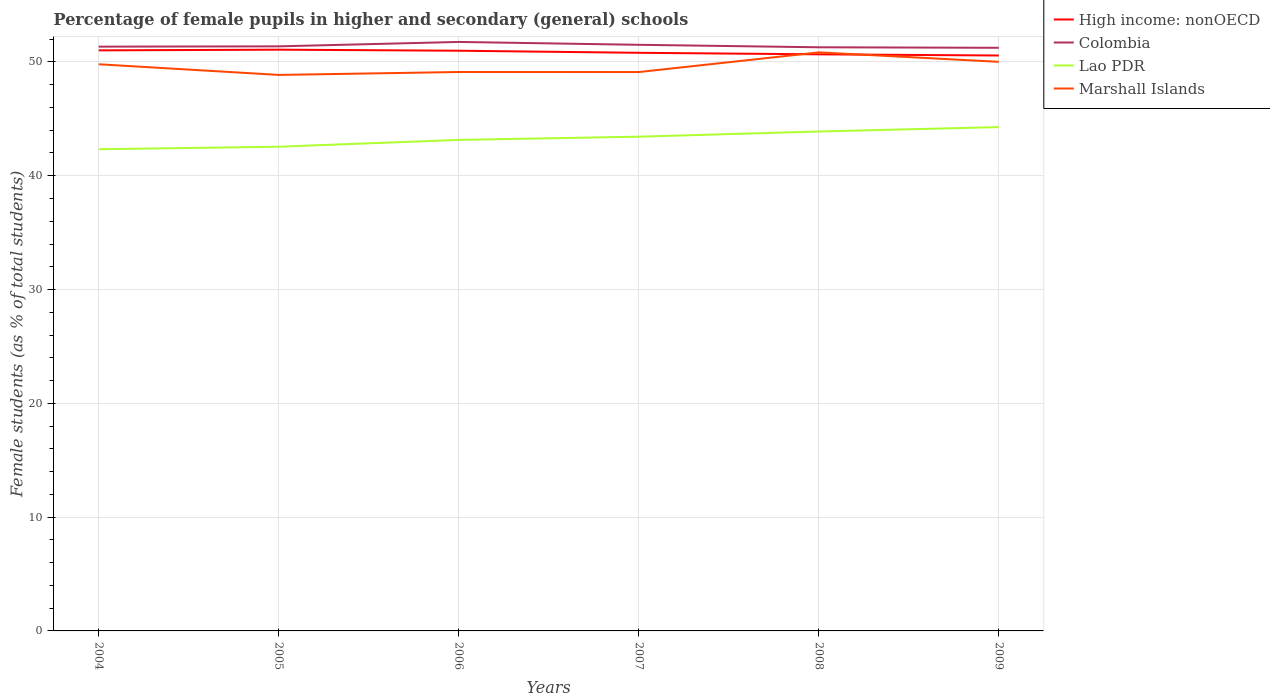Is the number of lines equal to the number of legend labels?
Provide a succinct answer. Yes. Across all years, what is the maximum percentage of female pupils in higher and secondary schools in High income: nonOECD?
Make the answer very short. 50.57. What is the total percentage of female pupils in higher and secondary schools in Colombia in the graph?
Provide a short and direct response. -0.03. What is the difference between the highest and the second highest percentage of female pupils in higher and secondary schools in Marshall Islands?
Your response must be concise. 1.98. Is the percentage of female pupils in higher and secondary schools in High income: nonOECD strictly greater than the percentage of female pupils in higher and secondary schools in Lao PDR over the years?
Your answer should be compact. No. How many lines are there?
Make the answer very short. 4. What is the difference between two consecutive major ticks on the Y-axis?
Your answer should be very brief. 10. Are the values on the major ticks of Y-axis written in scientific E-notation?
Your response must be concise. No. Does the graph contain any zero values?
Ensure brevity in your answer.  No. Does the graph contain grids?
Your answer should be very brief. Yes. How many legend labels are there?
Your answer should be very brief. 4. What is the title of the graph?
Provide a short and direct response. Percentage of female pupils in higher and secondary (general) schools. Does "Bhutan" appear as one of the legend labels in the graph?
Keep it short and to the point. No. What is the label or title of the Y-axis?
Give a very brief answer. Female students (as % of total students). What is the Female students (as % of total students) of High income: nonOECD in 2004?
Your answer should be compact. 51.02. What is the Female students (as % of total students) in Colombia in 2004?
Offer a terse response. 51.34. What is the Female students (as % of total students) in Lao PDR in 2004?
Make the answer very short. 42.33. What is the Female students (as % of total students) in Marshall Islands in 2004?
Offer a terse response. 49.79. What is the Female students (as % of total students) in High income: nonOECD in 2005?
Provide a succinct answer. 51.08. What is the Female students (as % of total students) in Colombia in 2005?
Ensure brevity in your answer.  51.37. What is the Female students (as % of total students) in Lao PDR in 2005?
Give a very brief answer. 42.55. What is the Female students (as % of total students) of Marshall Islands in 2005?
Your response must be concise. 48.86. What is the Female students (as % of total students) in High income: nonOECD in 2006?
Provide a succinct answer. 50.99. What is the Female students (as % of total students) of Colombia in 2006?
Provide a short and direct response. 51.76. What is the Female students (as % of total students) of Lao PDR in 2006?
Offer a terse response. 43.15. What is the Female students (as % of total students) in Marshall Islands in 2006?
Offer a terse response. 49.12. What is the Female students (as % of total students) in High income: nonOECD in 2007?
Provide a short and direct response. 50.8. What is the Female students (as % of total students) in Colombia in 2007?
Provide a short and direct response. 51.51. What is the Female students (as % of total students) in Lao PDR in 2007?
Your answer should be compact. 43.43. What is the Female students (as % of total students) in Marshall Islands in 2007?
Give a very brief answer. 49.11. What is the Female students (as % of total students) of High income: nonOECD in 2008?
Your response must be concise. 50.67. What is the Female students (as % of total students) of Colombia in 2008?
Ensure brevity in your answer.  51.29. What is the Female students (as % of total students) of Lao PDR in 2008?
Keep it short and to the point. 43.89. What is the Female students (as % of total students) in Marshall Islands in 2008?
Provide a succinct answer. 50.84. What is the Female students (as % of total students) in High income: nonOECD in 2009?
Offer a very short reply. 50.57. What is the Female students (as % of total students) of Colombia in 2009?
Make the answer very short. 51.24. What is the Female students (as % of total students) of Lao PDR in 2009?
Provide a succinct answer. 44.27. What is the Female students (as % of total students) in Marshall Islands in 2009?
Keep it short and to the point. 50.01. Across all years, what is the maximum Female students (as % of total students) in High income: nonOECD?
Provide a short and direct response. 51.08. Across all years, what is the maximum Female students (as % of total students) in Colombia?
Keep it short and to the point. 51.76. Across all years, what is the maximum Female students (as % of total students) of Lao PDR?
Offer a very short reply. 44.27. Across all years, what is the maximum Female students (as % of total students) in Marshall Islands?
Give a very brief answer. 50.84. Across all years, what is the minimum Female students (as % of total students) in High income: nonOECD?
Offer a terse response. 50.57. Across all years, what is the minimum Female students (as % of total students) of Colombia?
Your answer should be compact. 51.24. Across all years, what is the minimum Female students (as % of total students) of Lao PDR?
Your answer should be very brief. 42.33. Across all years, what is the minimum Female students (as % of total students) of Marshall Islands?
Your response must be concise. 48.86. What is the total Female students (as % of total students) of High income: nonOECD in the graph?
Offer a very short reply. 305.12. What is the total Female students (as % of total students) in Colombia in the graph?
Offer a very short reply. 308.51. What is the total Female students (as % of total students) in Lao PDR in the graph?
Offer a terse response. 259.62. What is the total Female students (as % of total students) in Marshall Islands in the graph?
Your answer should be very brief. 297.73. What is the difference between the Female students (as % of total students) of High income: nonOECD in 2004 and that in 2005?
Offer a terse response. -0.06. What is the difference between the Female students (as % of total students) in Colombia in 2004 and that in 2005?
Provide a succinct answer. -0.03. What is the difference between the Female students (as % of total students) in Lao PDR in 2004 and that in 2005?
Give a very brief answer. -0.22. What is the difference between the Female students (as % of total students) in Marshall Islands in 2004 and that in 2005?
Ensure brevity in your answer.  0.94. What is the difference between the Female students (as % of total students) in High income: nonOECD in 2004 and that in 2006?
Offer a very short reply. 0.03. What is the difference between the Female students (as % of total students) of Colombia in 2004 and that in 2006?
Your answer should be compact. -0.41. What is the difference between the Female students (as % of total students) of Lao PDR in 2004 and that in 2006?
Offer a very short reply. -0.82. What is the difference between the Female students (as % of total students) of Marshall Islands in 2004 and that in 2006?
Ensure brevity in your answer.  0.68. What is the difference between the Female students (as % of total students) in High income: nonOECD in 2004 and that in 2007?
Your answer should be compact. 0.21. What is the difference between the Female students (as % of total students) of Colombia in 2004 and that in 2007?
Offer a terse response. -0.16. What is the difference between the Female students (as % of total students) in Lao PDR in 2004 and that in 2007?
Your answer should be very brief. -1.1. What is the difference between the Female students (as % of total students) in Marshall Islands in 2004 and that in 2007?
Provide a short and direct response. 0.68. What is the difference between the Female students (as % of total students) in High income: nonOECD in 2004 and that in 2008?
Your answer should be very brief. 0.35. What is the difference between the Female students (as % of total students) in Colombia in 2004 and that in 2008?
Your answer should be very brief. 0.06. What is the difference between the Female students (as % of total students) of Lao PDR in 2004 and that in 2008?
Offer a very short reply. -1.56. What is the difference between the Female students (as % of total students) in Marshall Islands in 2004 and that in 2008?
Provide a succinct answer. -1.05. What is the difference between the Female students (as % of total students) in High income: nonOECD in 2004 and that in 2009?
Your answer should be very brief. 0.45. What is the difference between the Female students (as % of total students) in Colombia in 2004 and that in 2009?
Offer a terse response. 0.1. What is the difference between the Female students (as % of total students) of Lao PDR in 2004 and that in 2009?
Provide a succinct answer. -1.95. What is the difference between the Female students (as % of total students) in Marshall Islands in 2004 and that in 2009?
Ensure brevity in your answer.  -0.21. What is the difference between the Female students (as % of total students) in High income: nonOECD in 2005 and that in 2006?
Offer a terse response. 0.09. What is the difference between the Female students (as % of total students) of Colombia in 2005 and that in 2006?
Your answer should be compact. -0.39. What is the difference between the Female students (as % of total students) of Lao PDR in 2005 and that in 2006?
Offer a very short reply. -0.6. What is the difference between the Female students (as % of total students) in Marshall Islands in 2005 and that in 2006?
Keep it short and to the point. -0.26. What is the difference between the Female students (as % of total students) of High income: nonOECD in 2005 and that in 2007?
Your answer should be very brief. 0.28. What is the difference between the Female students (as % of total students) of Colombia in 2005 and that in 2007?
Provide a short and direct response. -0.14. What is the difference between the Female students (as % of total students) of Lao PDR in 2005 and that in 2007?
Provide a succinct answer. -0.88. What is the difference between the Female students (as % of total students) of Marshall Islands in 2005 and that in 2007?
Offer a very short reply. -0.25. What is the difference between the Female students (as % of total students) in High income: nonOECD in 2005 and that in 2008?
Provide a short and direct response. 0.41. What is the difference between the Female students (as % of total students) in Colombia in 2005 and that in 2008?
Your answer should be very brief. 0.08. What is the difference between the Female students (as % of total students) in Lao PDR in 2005 and that in 2008?
Give a very brief answer. -1.34. What is the difference between the Female students (as % of total students) in Marshall Islands in 2005 and that in 2008?
Offer a very short reply. -1.98. What is the difference between the Female students (as % of total students) in High income: nonOECD in 2005 and that in 2009?
Your answer should be very brief. 0.51. What is the difference between the Female students (as % of total students) of Colombia in 2005 and that in 2009?
Your answer should be compact. 0.13. What is the difference between the Female students (as % of total students) in Lao PDR in 2005 and that in 2009?
Give a very brief answer. -1.72. What is the difference between the Female students (as % of total students) of Marshall Islands in 2005 and that in 2009?
Provide a succinct answer. -1.15. What is the difference between the Female students (as % of total students) in High income: nonOECD in 2006 and that in 2007?
Offer a very short reply. 0.18. What is the difference between the Female students (as % of total students) of Colombia in 2006 and that in 2007?
Your answer should be very brief. 0.25. What is the difference between the Female students (as % of total students) in Lao PDR in 2006 and that in 2007?
Offer a very short reply. -0.28. What is the difference between the Female students (as % of total students) of Marshall Islands in 2006 and that in 2007?
Offer a terse response. 0. What is the difference between the Female students (as % of total students) of High income: nonOECD in 2006 and that in 2008?
Keep it short and to the point. 0.32. What is the difference between the Female students (as % of total students) in Colombia in 2006 and that in 2008?
Provide a short and direct response. 0.47. What is the difference between the Female students (as % of total students) of Lao PDR in 2006 and that in 2008?
Provide a succinct answer. -0.74. What is the difference between the Female students (as % of total students) in Marshall Islands in 2006 and that in 2008?
Your answer should be compact. -1.72. What is the difference between the Female students (as % of total students) of High income: nonOECD in 2006 and that in 2009?
Ensure brevity in your answer.  0.42. What is the difference between the Female students (as % of total students) of Colombia in 2006 and that in 2009?
Your answer should be very brief. 0.51. What is the difference between the Female students (as % of total students) of Lao PDR in 2006 and that in 2009?
Offer a terse response. -1.12. What is the difference between the Female students (as % of total students) of Marshall Islands in 2006 and that in 2009?
Offer a terse response. -0.89. What is the difference between the Female students (as % of total students) in High income: nonOECD in 2007 and that in 2008?
Keep it short and to the point. 0.13. What is the difference between the Female students (as % of total students) in Colombia in 2007 and that in 2008?
Your answer should be compact. 0.22. What is the difference between the Female students (as % of total students) in Lao PDR in 2007 and that in 2008?
Offer a very short reply. -0.46. What is the difference between the Female students (as % of total students) of Marshall Islands in 2007 and that in 2008?
Keep it short and to the point. -1.73. What is the difference between the Female students (as % of total students) of High income: nonOECD in 2007 and that in 2009?
Keep it short and to the point. 0.24. What is the difference between the Female students (as % of total students) of Colombia in 2007 and that in 2009?
Keep it short and to the point. 0.26. What is the difference between the Female students (as % of total students) of Lao PDR in 2007 and that in 2009?
Ensure brevity in your answer.  -0.84. What is the difference between the Female students (as % of total students) of Marshall Islands in 2007 and that in 2009?
Offer a terse response. -0.9. What is the difference between the Female students (as % of total students) in High income: nonOECD in 2008 and that in 2009?
Provide a succinct answer. 0.1. What is the difference between the Female students (as % of total students) of Colombia in 2008 and that in 2009?
Offer a very short reply. 0.04. What is the difference between the Female students (as % of total students) of Lao PDR in 2008 and that in 2009?
Make the answer very short. -0.38. What is the difference between the Female students (as % of total students) in Marshall Islands in 2008 and that in 2009?
Ensure brevity in your answer.  0.83. What is the difference between the Female students (as % of total students) in High income: nonOECD in 2004 and the Female students (as % of total students) in Colombia in 2005?
Give a very brief answer. -0.35. What is the difference between the Female students (as % of total students) of High income: nonOECD in 2004 and the Female students (as % of total students) of Lao PDR in 2005?
Ensure brevity in your answer.  8.47. What is the difference between the Female students (as % of total students) of High income: nonOECD in 2004 and the Female students (as % of total students) of Marshall Islands in 2005?
Make the answer very short. 2.16. What is the difference between the Female students (as % of total students) in Colombia in 2004 and the Female students (as % of total students) in Lao PDR in 2005?
Your answer should be compact. 8.79. What is the difference between the Female students (as % of total students) in Colombia in 2004 and the Female students (as % of total students) in Marshall Islands in 2005?
Give a very brief answer. 2.48. What is the difference between the Female students (as % of total students) in Lao PDR in 2004 and the Female students (as % of total students) in Marshall Islands in 2005?
Offer a very short reply. -6.53. What is the difference between the Female students (as % of total students) of High income: nonOECD in 2004 and the Female students (as % of total students) of Colombia in 2006?
Offer a terse response. -0.74. What is the difference between the Female students (as % of total students) of High income: nonOECD in 2004 and the Female students (as % of total students) of Lao PDR in 2006?
Keep it short and to the point. 7.87. What is the difference between the Female students (as % of total students) of High income: nonOECD in 2004 and the Female students (as % of total students) of Marshall Islands in 2006?
Ensure brevity in your answer.  1.9. What is the difference between the Female students (as % of total students) in Colombia in 2004 and the Female students (as % of total students) in Lao PDR in 2006?
Give a very brief answer. 8.19. What is the difference between the Female students (as % of total students) in Colombia in 2004 and the Female students (as % of total students) in Marshall Islands in 2006?
Your answer should be very brief. 2.23. What is the difference between the Female students (as % of total students) in Lao PDR in 2004 and the Female students (as % of total students) in Marshall Islands in 2006?
Ensure brevity in your answer.  -6.79. What is the difference between the Female students (as % of total students) in High income: nonOECD in 2004 and the Female students (as % of total students) in Colombia in 2007?
Your answer should be compact. -0.49. What is the difference between the Female students (as % of total students) of High income: nonOECD in 2004 and the Female students (as % of total students) of Lao PDR in 2007?
Provide a succinct answer. 7.59. What is the difference between the Female students (as % of total students) in High income: nonOECD in 2004 and the Female students (as % of total students) in Marshall Islands in 2007?
Offer a very short reply. 1.91. What is the difference between the Female students (as % of total students) in Colombia in 2004 and the Female students (as % of total students) in Lao PDR in 2007?
Offer a very short reply. 7.91. What is the difference between the Female students (as % of total students) of Colombia in 2004 and the Female students (as % of total students) of Marshall Islands in 2007?
Your answer should be compact. 2.23. What is the difference between the Female students (as % of total students) of Lao PDR in 2004 and the Female students (as % of total students) of Marshall Islands in 2007?
Offer a very short reply. -6.78. What is the difference between the Female students (as % of total students) of High income: nonOECD in 2004 and the Female students (as % of total students) of Colombia in 2008?
Ensure brevity in your answer.  -0.27. What is the difference between the Female students (as % of total students) in High income: nonOECD in 2004 and the Female students (as % of total students) in Lao PDR in 2008?
Offer a terse response. 7.13. What is the difference between the Female students (as % of total students) in High income: nonOECD in 2004 and the Female students (as % of total students) in Marshall Islands in 2008?
Ensure brevity in your answer.  0.18. What is the difference between the Female students (as % of total students) of Colombia in 2004 and the Female students (as % of total students) of Lao PDR in 2008?
Provide a short and direct response. 7.45. What is the difference between the Female students (as % of total students) in Colombia in 2004 and the Female students (as % of total students) in Marshall Islands in 2008?
Give a very brief answer. 0.5. What is the difference between the Female students (as % of total students) in Lao PDR in 2004 and the Female students (as % of total students) in Marshall Islands in 2008?
Provide a short and direct response. -8.51. What is the difference between the Female students (as % of total students) of High income: nonOECD in 2004 and the Female students (as % of total students) of Colombia in 2009?
Keep it short and to the point. -0.23. What is the difference between the Female students (as % of total students) of High income: nonOECD in 2004 and the Female students (as % of total students) of Lao PDR in 2009?
Your response must be concise. 6.74. What is the difference between the Female students (as % of total students) of High income: nonOECD in 2004 and the Female students (as % of total students) of Marshall Islands in 2009?
Provide a short and direct response. 1.01. What is the difference between the Female students (as % of total students) in Colombia in 2004 and the Female students (as % of total students) in Lao PDR in 2009?
Offer a terse response. 7.07. What is the difference between the Female students (as % of total students) in Colombia in 2004 and the Female students (as % of total students) in Marshall Islands in 2009?
Give a very brief answer. 1.33. What is the difference between the Female students (as % of total students) in Lao PDR in 2004 and the Female students (as % of total students) in Marshall Islands in 2009?
Provide a succinct answer. -7.68. What is the difference between the Female students (as % of total students) of High income: nonOECD in 2005 and the Female students (as % of total students) of Colombia in 2006?
Give a very brief answer. -0.68. What is the difference between the Female students (as % of total students) in High income: nonOECD in 2005 and the Female students (as % of total students) in Lao PDR in 2006?
Your response must be concise. 7.93. What is the difference between the Female students (as % of total students) in High income: nonOECD in 2005 and the Female students (as % of total students) in Marshall Islands in 2006?
Give a very brief answer. 1.96. What is the difference between the Female students (as % of total students) in Colombia in 2005 and the Female students (as % of total students) in Lao PDR in 2006?
Provide a succinct answer. 8.22. What is the difference between the Female students (as % of total students) of Colombia in 2005 and the Female students (as % of total students) of Marshall Islands in 2006?
Your response must be concise. 2.25. What is the difference between the Female students (as % of total students) of Lao PDR in 2005 and the Female students (as % of total students) of Marshall Islands in 2006?
Your answer should be compact. -6.57. What is the difference between the Female students (as % of total students) in High income: nonOECD in 2005 and the Female students (as % of total students) in Colombia in 2007?
Your answer should be compact. -0.43. What is the difference between the Female students (as % of total students) of High income: nonOECD in 2005 and the Female students (as % of total students) of Lao PDR in 2007?
Your answer should be compact. 7.65. What is the difference between the Female students (as % of total students) of High income: nonOECD in 2005 and the Female students (as % of total students) of Marshall Islands in 2007?
Ensure brevity in your answer.  1.97. What is the difference between the Female students (as % of total students) in Colombia in 2005 and the Female students (as % of total students) in Lao PDR in 2007?
Offer a terse response. 7.94. What is the difference between the Female students (as % of total students) of Colombia in 2005 and the Female students (as % of total students) of Marshall Islands in 2007?
Your answer should be very brief. 2.26. What is the difference between the Female students (as % of total students) of Lao PDR in 2005 and the Female students (as % of total students) of Marshall Islands in 2007?
Keep it short and to the point. -6.56. What is the difference between the Female students (as % of total students) of High income: nonOECD in 2005 and the Female students (as % of total students) of Colombia in 2008?
Offer a terse response. -0.21. What is the difference between the Female students (as % of total students) in High income: nonOECD in 2005 and the Female students (as % of total students) in Lao PDR in 2008?
Ensure brevity in your answer.  7.19. What is the difference between the Female students (as % of total students) in High income: nonOECD in 2005 and the Female students (as % of total students) in Marshall Islands in 2008?
Offer a terse response. 0.24. What is the difference between the Female students (as % of total students) of Colombia in 2005 and the Female students (as % of total students) of Lao PDR in 2008?
Provide a succinct answer. 7.48. What is the difference between the Female students (as % of total students) in Colombia in 2005 and the Female students (as % of total students) in Marshall Islands in 2008?
Give a very brief answer. 0.53. What is the difference between the Female students (as % of total students) of Lao PDR in 2005 and the Female students (as % of total students) of Marshall Islands in 2008?
Provide a short and direct response. -8.29. What is the difference between the Female students (as % of total students) in High income: nonOECD in 2005 and the Female students (as % of total students) in Colombia in 2009?
Make the answer very short. -0.16. What is the difference between the Female students (as % of total students) of High income: nonOECD in 2005 and the Female students (as % of total students) of Lao PDR in 2009?
Keep it short and to the point. 6.8. What is the difference between the Female students (as % of total students) of High income: nonOECD in 2005 and the Female students (as % of total students) of Marshall Islands in 2009?
Your answer should be compact. 1.07. What is the difference between the Female students (as % of total students) of Colombia in 2005 and the Female students (as % of total students) of Lao PDR in 2009?
Give a very brief answer. 7.1. What is the difference between the Female students (as % of total students) in Colombia in 2005 and the Female students (as % of total students) in Marshall Islands in 2009?
Your response must be concise. 1.36. What is the difference between the Female students (as % of total students) in Lao PDR in 2005 and the Female students (as % of total students) in Marshall Islands in 2009?
Keep it short and to the point. -7.46. What is the difference between the Female students (as % of total students) of High income: nonOECD in 2006 and the Female students (as % of total students) of Colombia in 2007?
Provide a succinct answer. -0.52. What is the difference between the Female students (as % of total students) of High income: nonOECD in 2006 and the Female students (as % of total students) of Lao PDR in 2007?
Your answer should be very brief. 7.55. What is the difference between the Female students (as % of total students) of High income: nonOECD in 2006 and the Female students (as % of total students) of Marshall Islands in 2007?
Give a very brief answer. 1.88. What is the difference between the Female students (as % of total students) in Colombia in 2006 and the Female students (as % of total students) in Lao PDR in 2007?
Offer a very short reply. 8.33. What is the difference between the Female students (as % of total students) in Colombia in 2006 and the Female students (as % of total students) in Marshall Islands in 2007?
Your answer should be very brief. 2.65. What is the difference between the Female students (as % of total students) of Lao PDR in 2006 and the Female students (as % of total students) of Marshall Islands in 2007?
Keep it short and to the point. -5.96. What is the difference between the Female students (as % of total students) of High income: nonOECD in 2006 and the Female students (as % of total students) of Colombia in 2008?
Offer a terse response. -0.3. What is the difference between the Female students (as % of total students) in High income: nonOECD in 2006 and the Female students (as % of total students) in Lao PDR in 2008?
Make the answer very short. 7.1. What is the difference between the Female students (as % of total students) of High income: nonOECD in 2006 and the Female students (as % of total students) of Marshall Islands in 2008?
Provide a short and direct response. 0.15. What is the difference between the Female students (as % of total students) in Colombia in 2006 and the Female students (as % of total students) in Lao PDR in 2008?
Provide a short and direct response. 7.87. What is the difference between the Female students (as % of total students) in Colombia in 2006 and the Female students (as % of total students) in Marshall Islands in 2008?
Provide a succinct answer. 0.92. What is the difference between the Female students (as % of total students) in Lao PDR in 2006 and the Female students (as % of total students) in Marshall Islands in 2008?
Your answer should be compact. -7.69. What is the difference between the Female students (as % of total students) in High income: nonOECD in 2006 and the Female students (as % of total students) in Colombia in 2009?
Offer a very short reply. -0.26. What is the difference between the Female students (as % of total students) in High income: nonOECD in 2006 and the Female students (as % of total students) in Lao PDR in 2009?
Offer a very short reply. 6.71. What is the difference between the Female students (as % of total students) of High income: nonOECD in 2006 and the Female students (as % of total students) of Marshall Islands in 2009?
Make the answer very short. 0.98. What is the difference between the Female students (as % of total students) of Colombia in 2006 and the Female students (as % of total students) of Lao PDR in 2009?
Offer a very short reply. 7.48. What is the difference between the Female students (as % of total students) in Colombia in 2006 and the Female students (as % of total students) in Marshall Islands in 2009?
Your answer should be very brief. 1.75. What is the difference between the Female students (as % of total students) of Lao PDR in 2006 and the Female students (as % of total students) of Marshall Islands in 2009?
Offer a very short reply. -6.86. What is the difference between the Female students (as % of total students) of High income: nonOECD in 2007 and the Female students (as % of total students) of Colombia in 2008?
Keep it short and to the point. -0.48. What is the difference between the Female students (as % of total students) of High income: nonOECD in 2007 and the Female students (as % of total students) of Lao PDR in 2008?
Make the answer very short. 6.91. What is the difference between the Female students (as % of total students) in High income: nonOECD in 2007 and the Female students (as % of total students) in Marshall Islands in 2008?
Your response must be concise. -0.04. What is the difference between the Female students (as % of total students) in Colombia in 2007 and the Female students (as % of total students) in Lao PDR in 2008?
Make the answer very short. 7.62. What is the difference between the Female students (as % of total students) in Colombia in 2007 and the Female students (as % of total students) in Marshall Islands in 2008?
Provide a succinct answer. 0.67. What is the difference between the Female students (as % of total students) in Lao PDR in 2007 and the Female students (as % of total students) in Marshall Islands in 2008?
Your answer should be very brief. -7.41. What is the difference between the Female students (as % of total students) of High income: nonOECD in 2007 and the Female students (as % of total students) of Colombia in 2009?
Keep it short and to the point. -0.44. What is the difference between the Female students (as % of total students) of High income: nonOECD in 2007 and the Female students (as % of total students) of Lao PDR in 2009?
Offer a terse response. 6.53. What is the difference between the Female students (as % of total students) in High income: nonOECD in 2007 and the Female students (as % of total students) in Marshall Islands in 2009?
Offer a very short reply. 0.79. What is the difference between the Female students (as % of total students) of Colombia in 2007 and the Female students (as % of total students) of Lao PDR in 2009?
Give a very brief answer. 7.23. What is the difference between the Female students (as % of total students) in Colombia in 2007 and the Female students (as % of total students) in Marshall Islands in 2009?
Ensure brevity in your answer.  1.5. What is the difference between the Female students (as % of total students) in Lao PDR in 2007 and the Female students (as % of total students) in Marshall Islands in 2009?
Offer a terse response. -6.58. What is the difference between the Female students (as % of total students) in High income: nonOECD in 2008 and the Female students (as % of total students) in Colombia in 2009?
Provide a short and direct response. -0.57. What is the difference between the Female students (as % of total students) in High income: nonOECD in 2008 and the Female students (as % of total students) in Lao PDR in 2009?
Ensure brevity in your answer.  6.39. What is the difference between the Female students (as % of total students) of High income: nonOECD in 2008 and the Female students (as % of total students) of Marshall Islands in 2009?
Make the answer very short. 0.66. What is the difference between the Female students (as % of total students) in Colombia in 2008 and the Female students (as % of total students) in Lao PDR in 2009?
Your answer should be very brief. 7.01. What is the difference between the Female students (as % of total students) in Colombia in 2008 and the Female students (as % of total students) in Marshall Islands in 2009?
Your answer should be very brief. 1.28. What is the difference between the Female students (as % of total students) in Lao PDR in 2008 and the Female students (as % of total students) in Marshall Islands in 2009?
Your response must be concise. -6.12. What is the average Female students (as % of total students) in High income: nonOECD per year?
Your answer should be very brief. 50.85. What is the average Female students (as % of total students) in Colombia per year?
Ensure brevity in your answer.  51.42. What is the average Female students (as % of total students) of Lao PDR per year?
Offer a terse response. 43.27. What is the average Female students (as % of total students) in Marshall Islands per year?
Provide a short and direct response. 49.62. In the year 2004, what is the difference between the Female students (as % of total students) in High income: nonOECD and Female students (as % of total students) in Colombia?
Provide a short and direct response. -0.33. In the year 2004, what is the difference between the Female students (as % of total students) of High income: nonOECD and Female students (as % of total students) of Lao PDR?
Offer a very short reply. 8.69. In the year 2004, what is the difference between the Female students (as % of total students) in High income: nonOECD and Female students (as % of total students) in Marshall Islands?
Offer a very short reply. 1.22. In the year 2004, what is the difference between the Female students (as % of total students) of Colombia and Female students (as % of total students) of Lao PDR?
Make the answer very short. 9.01. In the year 2004, what is the difference between the Female students (as % of total students) of Colombia and Female students (as % of total students) of Marshall Islands?
Offer a very short reply. 1.55. In the year 2004, what is the difference between the Female students (as % of total students) in Lao PDR and Female students (as % of total students) in Marshall Islands?
Your response must be concise. -7.47. In the year 2005, what is the difference between the Female students (as % of total students) of High income: nonOECD and Female students (as % of total students) of Colombia?
Provide a succinct answer. -0.29. In the year 2005, what is the difference between the Female students (as % of total students) of High income: nonOECD and Female students (as % of total students) of Lao PDR?
Provide a short and direct response. 8.53. In the year 2005, what is the difference between the Female students (as % of total students) in High income: nonOECD and Female students (as % of total students) in Marshall Islands?
Ensure brevity in your answer.  2.22. In the year 2005, what is the difference between the Female students (as % of total students) in Colombia and Female students (as % of total students) in Lao PDR?
Make the answer very short. 8.82. In the year 2005, what is the difference between the Female students (as % of total students) of Colombia and Female students (as % of total students) of Marshall Islands?
Your answer should be compact. 2.51. In the year 2005, what is the difference between the Female students (as % of total students) in Lao PDR and Female students (as % of total students) in Marshall Islands?
Keep it short and to the point. -6.31. In the year 2006, what is the difference between the Female students (as % of total students) of High income: nonOECD and Female students (as % of total students) of Colombia?
Your answer should be very brief. -0.77. In the year 2006, what is the difference between the Female students (as % of total students) in High income: nonOECD and Female students (as % of total students) in Lao PDR?
Provide a succinct answer. 7.84. In the year 2006, what is the difference between the Female students (as % of total students) in High income: nonOECD and Female students (as % of total students) in Marshall Islands?
Offer a very short reply. 1.87. In the year 2006, what is the difference between the Female students (as % of total students) in Colombia and Female students (as % of total students) in Lao PDR?
Ensure brevity in your answer.  8.61. In the year 2006, what is the difference between the Female students (as % of total students) of Colombia and Female students (as % of total students) of Marshall Islands?
Offer a terse response. 2.64. In the year 2006, what is the difference between the Female students (as % of total students) of Lao PDR and Female students (as % of total students) of Marshall Islands?
Provide a short and direct response. -5.97. In the year 2007, what is the difference between the Female students (as % of total students) in High income: nonOECD and Female students (as % of total students) in Colombia?
Your answer should be very brief. -0.7. In the year 2007, what is the difference between the Female students (as % of total students) of High income: nonOECD and Female students (as % of total students) of Lao PDR?
Keep it short and to the point. 7.37. In the year 2007, what is the difference between the Female students (as % of total students) of High income: nonOECD and Female students (as % of total students) of Marshall Islands?
Your answer should be compact. 1.69. In the year 2007, what is the difference between the Female students (as % of total students) of Colombia and Female students (as % of total students) of Lao PDR?
Your answer should be very brief. 8.07. In the year 2007, what is the difference between the Female students (as % of total students) in Colombia and Female students (as % of total students) in Marshall Islands?
Your answer should be compact. 2.39. In the year 2007, what is the difference between the Female students (as % of total students) of Lao PDR and Female students (as % of total students) of Marshall Islands?
Provide a short and direct response. -5.68. In the year 2008, what is the difference between the Female students (as % of total students) in High income: nonOECD and Female students (as % of total students) in Colombia?
Keep it short and to the point. -0.62. In the year 2008, what is the difference between the Female students (as % of total students) of High income: nonOECD and Female students (as % of total students) of Lao PDR?
Your answer should be very brief. 6.78. In the year 2008, what is the difference between the Female students (as % of total students) in High income: nonOECD and Female students (as % of total students) in Marshall Islands?
Your response must be concise. -0.17. In the year 2008, what is the difference between the Female students (as % of total students) of Colombia and Female students (as % of total students) of Lao PDR?
Provide a short and direct response. 7.4. In the year 2008, what is the difference between the Female students (as % of total students) in Colombia and Female students (as % of total students) in Marshall Islands?
Give a very brief answer. 0.45. In the year 2008, what is the difference between the Female students (as % of total students) of Lao PDR and Female students (as % of total students) of Marshall Islands?
Offer a very short reply. -6.95. In the year 2009, what is the difference between the Female students (as % of total students) in High income: nonOECD and Female students (as % of total students) in Colombia?
Offer a very short reply. -0.68. In the year 2009, what is the difference between the Female students (as % of total students) of High income: nonOECD and Female students (as % of total students) of Lao PDR?
Provide a short and direct response. 6.29. In the year 2009, what is the difference between the Female students (as % of total students) of High income: nonOECD and Female students (as % of total students) of Marshall Islands?
Give a very brief answer. 0.56. In the year 2009, what is the difference between the Female students (as % of total students) in Colombia and Female students (as % of total students) in Lao PDR?
Your answer should be very brief. 6.97. In the year 2009, what is the difference between the Female students (as % of total students) in Colombia and Female students (as % of total students) in Marshall Islands?
Make the answer very short. 1.23. In the year 2009, what is the difference between the Female students (as % of total students) in Lao PDR and Female students (as % of total students) in Marshall Islands?
Ensure brevity in your answer.  -5.74. What is the ratio of the Female students (as % of total students) in Marshall Islands in 2004 to that in 2005?
Offer a very short reply. 1.02. What is the ratio of the Female students (as % of total students) in Colombia in 2004 to that in 2006?
Make the answer very short. 0.99. What is the ratio of the Female students (as % of total students) in Marshall Islands in 2004 to that in 2006?
Your answer should be compact. 1.01. What is the ratio of the Female students (as % of total students) of High income: nonOECD in 2004 to that in 2007?
Your response must be concise. 1. What is the ratio of the Female students (as % of total students) in Lao PDR in 2004 to that in 2007?
Your answer should be very brief. 0.97. What is the ratio of the Female students (as % of total students) of Marshall Islands in 2004 to that in 2007?
Make the answer very short. 1.01. What is the ratio of the Female students (as % of total students) in High income: nonOECD in 2004 to that in 2008?
Keep it short and to the point. 1.01. What is the ratio of the Female students (as % of total students) in Lao PDR in 2004 to that in 2008?
Offer a terse response. 0.96. What is the ratio of the Female students (as % of total students) of Marshall Islands in 2004 to that in 2008?
Your answer should be very brief. 0.98. What is the ratio of the Female students (as % of total students) of High income: nonOECD in 2004 to that in 2009?
Your answer should be very brief. 1.01. What is the ratio of the Female students (as % of total students) of Colombia in 2004 to that in 2009?
Provide a short and direct response. 1. What is the ratio of the Female students (as % of total students) in Lao PDR in 2004 to that in 2009?
Ensure brevity in your answer.  0.96. What is the ratio of the Female students (as % of total students) in Marshall Islands in 2004 to that in 2009?
Your answer should be compact. 1. What is the ratio of the Female students (as % of total students) in Lao PDR in 2005 to that in 2006?
Make the answer very short. 0.99. What is the ratio of the Female students (as % of total students) in Marshall Islands in 2005 to that in 2006?
Provide a short and direct response. 0.99. What is the ratio of the Female students (as % of total students) of High income: nonOECD in 2005 to that in 2007?
Give a very brief answer. 1.01. What is the ratio of the Female students (as % of total students) of Colombia in 2005 to that in 2007?
Give a very brief answer. 1. What is the ratio of the Female students (as % of total students) in Lao PDR in 2005 to that in 2007?
Give a very brief answer. 0.98. What is the ratio of the Female students (as % of total students) of Marshall Islands in 2005 to that in 2007?
Provide a short and direct response. 0.99. What is the ratio of the Female students (as % of total students) of Colombia in 2005 to that in 2008?
Make the answer very short. 1. What is the ratio of the Female students (as % of total students) of Lao PDR in 2005 to that in 2008?
Offer a terse response. 0.97. What is the ratio of the Female students (as % of total students) of Colombia in 2005 to that in 2009?
Keep it short and to the point. 1. What is the ratio of the Female students (as % of total students) of Lao PDR in 2005 to that in 2009?
Provide a succinct answer. 0.96. What is the ratio of the Female students (as % of total students) in Marshall Islands in 2005 to that in 2009?
Your answer should be compact. 0.98. What is the ratio of the Female students (as % of total students) in Colombia in 2006 to that in 2007?
Ensure brevity in your answer.  1. What is the ratio of the Female students (as % of total students) in Lao PDR in 2006 to that in 2007?
Offer a terse response. 0.99. What is the ratio of the Female students (as % of total students) of Colombia in 2006 to that in 2008?
Offer a terse response. 1.01. What is the ratio of the Female students (as % of total students) in Lao PDR in 2006 to that in 2008?
Provide a succinct answer. 0.98. What is the ratio of the Female students (as % of total students) in Marshall Islands in 2006 to that in 2008?
Your answer should be compact. 0.97. What is the ratio of the Female students (as % of total students) in High income: nonOECD in 2006 to that in 2009?
Provide a short and direct response. 1.01. What is the ratio of the Female students (as % of total students) of Colombia in 2006 to that in 2009?
Make the answer very short. 1.01. What is the ratio of the Female students (as % of total students) in Lao PDR in 2006 to that in 2009?
Ensure brevity in your answer.  0.97. What is the ratio of the Female students (as % of total students) in Marshall Islands in 2006 to that in 2009?
Ensure brevity in your answer.  0.98. What is the ratio of the Female students (as % of total students) in High income: nonOECD in 2007 to that in 2008?
Make the answer very short. 1. What is the ratio of the Female students (as % of total students) in High income: nonOECD in 2007 to that in 2009?
Your response must be concise. 1. What is the ratio of the Female students (as % of total students) in Colombia in 2007 to that in 2009?
Give a very brief answer. 1.01. What is the ratio of the Female students (as % of total students) in Colombia in 2008 to that in 2009?
Keep it short and to the point. 1. What is the ratio of the Female students (as % of total students) of Lao PDR in 2008 to that in 2009?
Provide a short and direct response. 0.99. What is the ratio of the Female students (as % of total students) of Marshall Islands in 2008 to that in 2009?
Offer a terse response. 1.02. What is the difference between the highest and the second highest Female students (as % of total students) of High income: nonOECD?
Make the answer very short. 0.06. What is the difference between the highest and the second highest Female students (as % of total students) of Colombia?
Provide a succinct answer. 0.25. What is the difference between the highest and the second highest Female students (as % of total students) in Lao PDR?
Your answer should be very brief. 0.38. What is the difference between the highest and the second highest Female students (as % of total students) in Marshall Islands?
Give a very brief answer. 0.83. What is the difference between the highest and the lowest Female students (as % of total students) of High income: nonOECD?
Your answer should be very brief. 0.51. What is the difference between the highest and the lowest Female students (as % of total students) in Colombia?
Your answer should be compact. 0.51. What is the difference between the highest and the lowest Female students (as % of total students) of Lao PDR?
Your answer should be compact. 1.95. What is the difference between the highest and the lowest Female students (as % of total students) in Marshall Islands?
Ensure brevity in your answer.  1.98. 